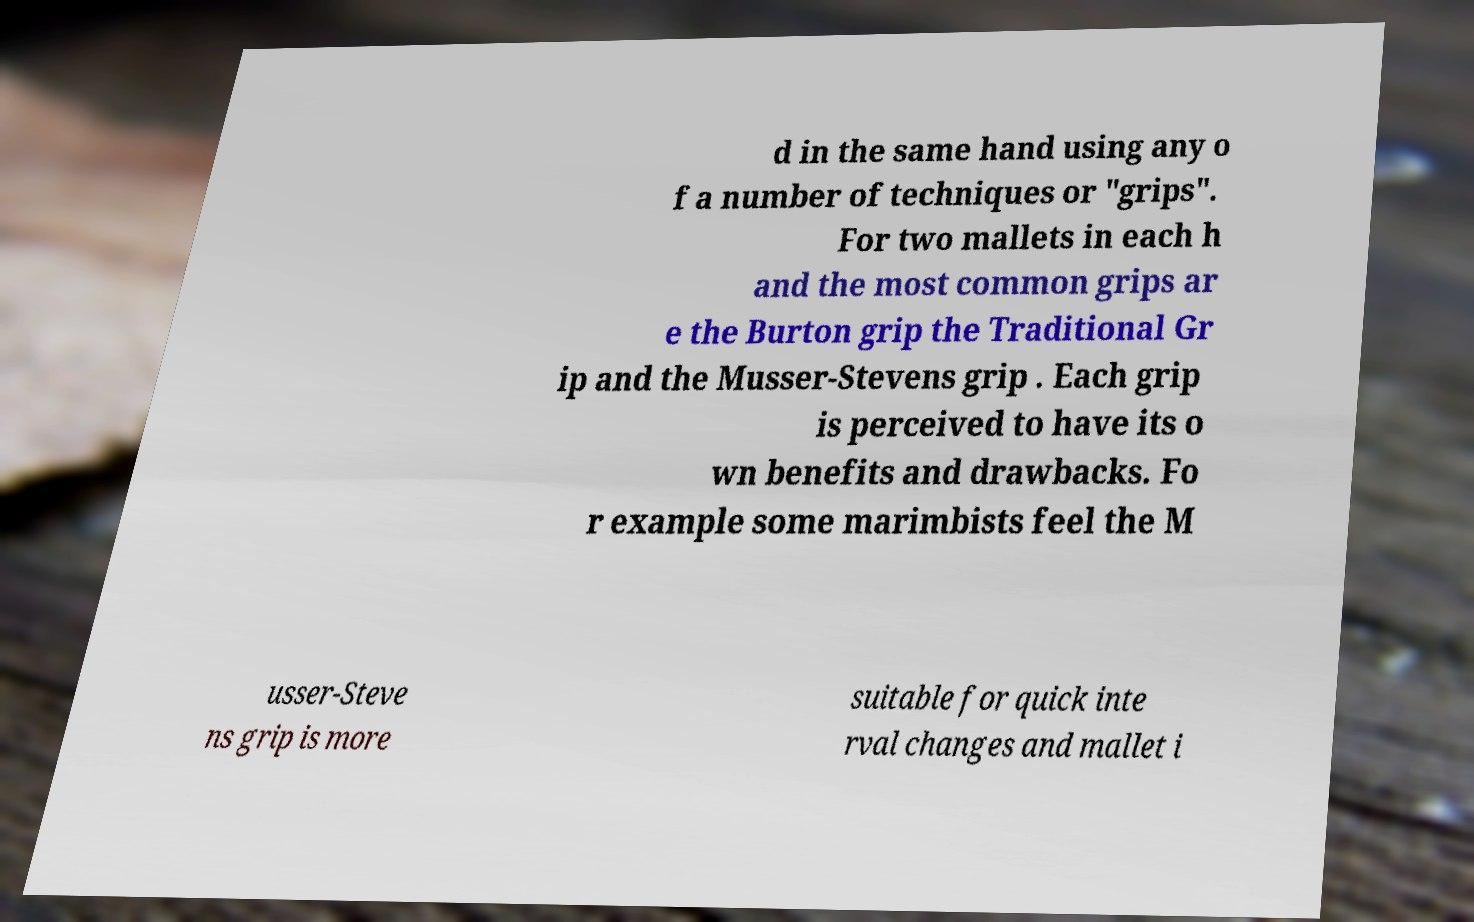I need the written content from this picture converted into text. Can you do that? d in the same hand using any o f a number of techniques or "grips". For two mallets in each h and the most common grips ar e the Burton grip the Traditional Gr ip and the Musser-Stevens grip . Each grip is perceived to have its o wn benefits and drawbacks. Fo r example some marimbists feel the M usser-Steve ns grip is more suitable for quick inte rval changes and mallet i 